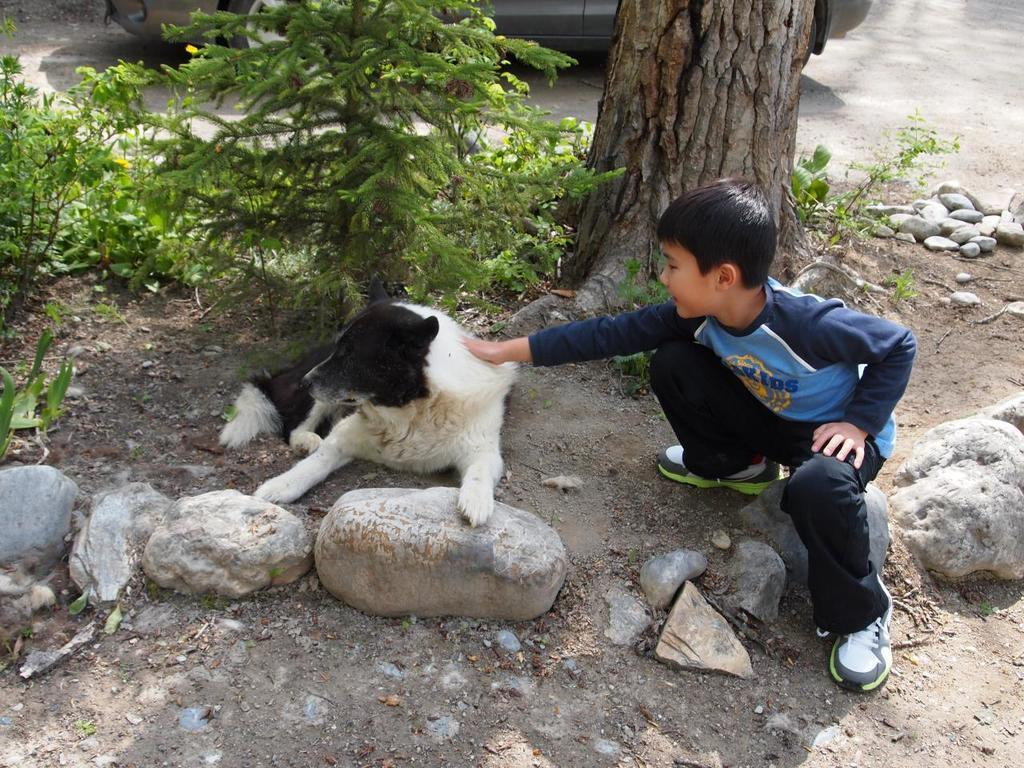Who or what is the main subject in the image? There is a boy in the image. What other living creature is present in the image? There is a dog in the image. What type of natural elements can be seen in the image? There is a tree and a plant in the image. Are there any man-made objects visible in the image? Yes, there is a car in the image. What is the ground covered with in the image? There are stones on the ground in the image. What type of cable can be seen connecting the boy and the dog in the image? There is no cable connecting the boy and the dog in the image; they are not physically connected. 